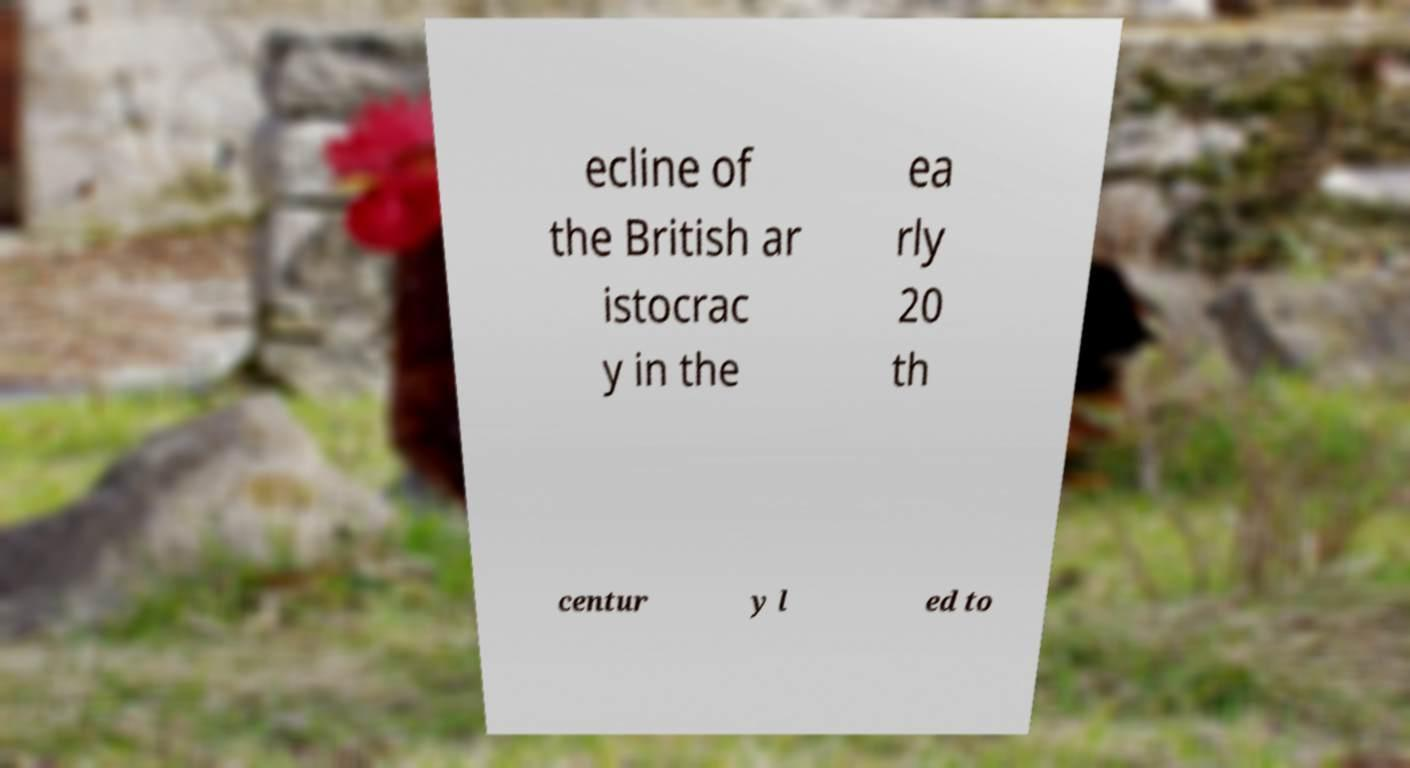Could you extract and type out the text from this image? ecline of the British ar istocrac y in the ea rly 20 th centur y l ed to 